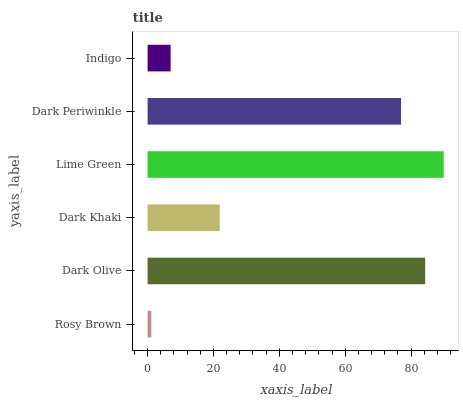Is Rosy Brown the minimum?
Answer yes or no. Yes. Is Lime Green the maximum?
Answer yes or no. Yes. Is Dark Olive the minimum?
Answer yes or no. No. Is Dark Olive the maximum?
Answer yes or no. No. Is Dark Olive greater than Rosy Brown?
Answer yes or no. Yes. Is Rosy Brown less than Dark Olive?
Answer yes or no. Yes. Is Rosy Brown greater than Dark Olive?
Answer yes or no. No. Is Dark Olive less than Rosy Brown?
Answer yes or no. No. Is Dark Periwinkle the high median?
Answer yes or no. Yes. Is Dark Khaki the low median?
Answer yes or no. Yes. Is Rosy Brown the high median?
Answer yes or no. No. Is Dark Olive the low median?
Answer yes or no. No. 